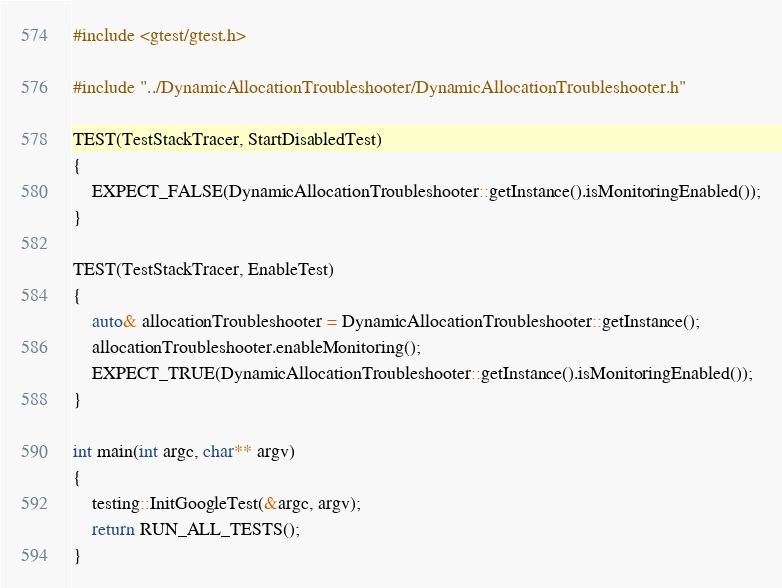<code> <loc_0><loc_0><loc_500><loc_500><_C++_>#include <gtest/gtest.h>

#include "../DynamicAllocationTroubleshooter/DynamicAllocationTroubleshooter.h"

TEST(TestStackTracer, StartDisabledTest)
{
    EXPECT_FALSE(DynamicAllocationTroubleshooter::getInstance().isMonitoringEnabled());
}

TEST(TestStackTracer, EnableTest)
{
    auto& allocationTroubleshooter = DynamicAllocationTroubleshooter::getInstance();
    allocationTroubleshooter.enableMonitoring();
    EXPECT_TRUE(DynamicAllocationTroubleshooter::getInstance().isMonitoringEnabled());
}

int main(int argc, char** argv)
{
    testing::InitGoogleTest(&argc, argv);
    return RUN_ALL_TESTS();
}
</code> 